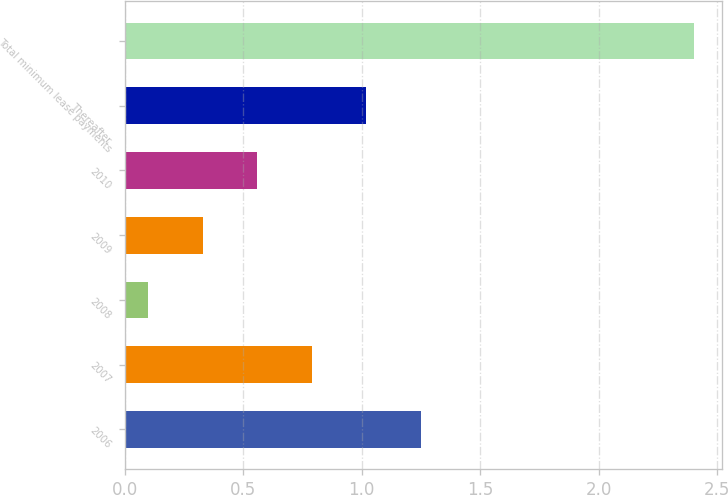Convert chart. <chart><loc_0><loc_0><loc_500><loc_500><bar_chart><fcel>2006<fcel>2007<fcel>2008<fcel>2009<fcel>2010<fcel>Thereafter<fcel>Total minimum lease payments<nl><fcel>1.25<fcel>0.79<fcel>0.1<fcel>0.33<fcel>0.56<fcel>1.02<fcel>2.4<nl></chart> 